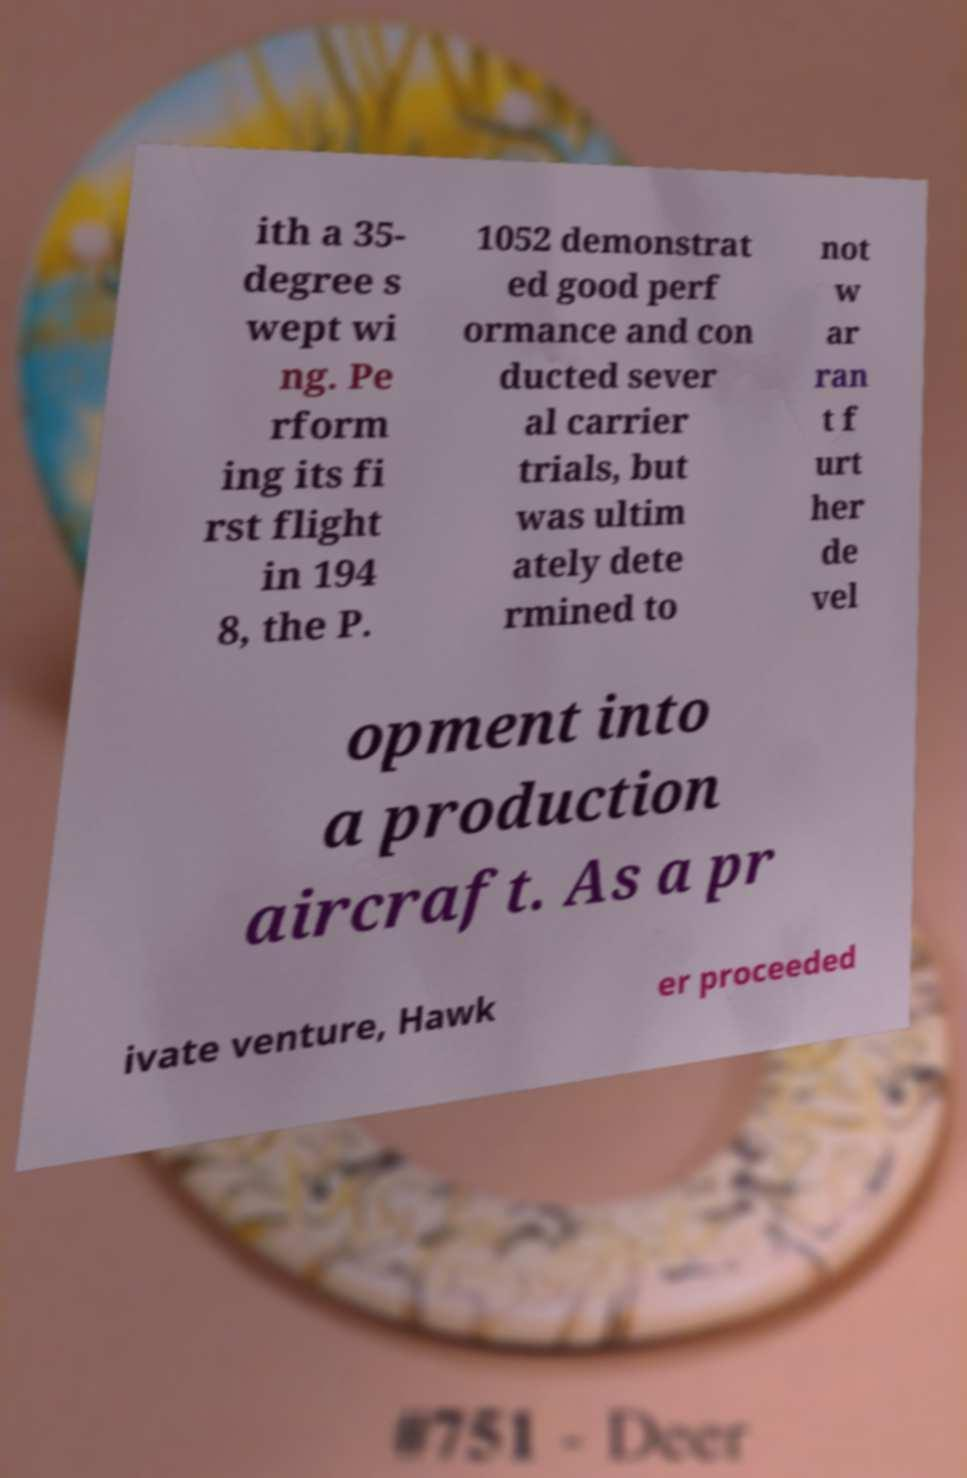I need the written content from this picture converted into text. Can you do that? ith a 35- degree s wept wi ng. Pe rform ing its fi rst flight in 194 8, the P. 1052 demonstrat ed good perf ormance and con ducted sever al carrier trials, but was ultim ately dete rmined to not w ar ran t f urt her de vel opment into a production aircraft. As a pr ivate venture, Hawk er proceeded 